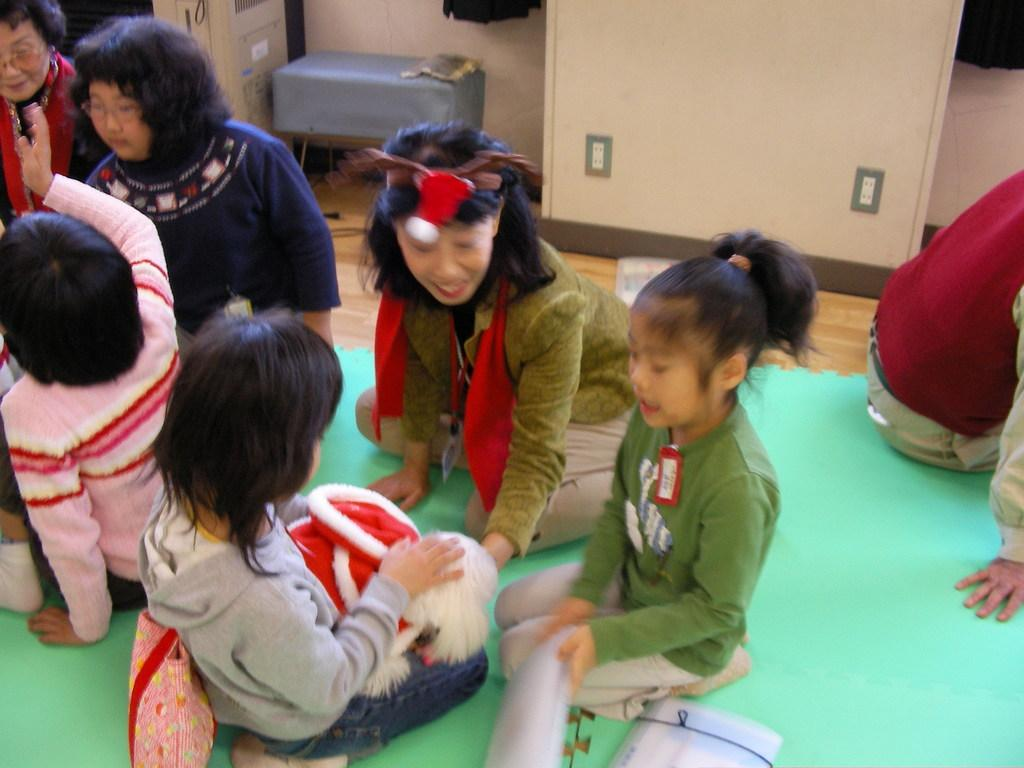Who is present in the image? There are kids in the image. What are the kids sitting on? The kids are sitting on a green carpet. What type of flooring is under the carpet? The carpet is on a wooden floor. What can be seen in the background of the image? There is a cupboard in the background of the image. What is in front of the wall in the image? There is a stool in front of the wall in the image. What type of muscle is being exercised by the kids in the image? There is no indication in the image that the kids are exercising any muscles; they are simply sitting on a carpet. 